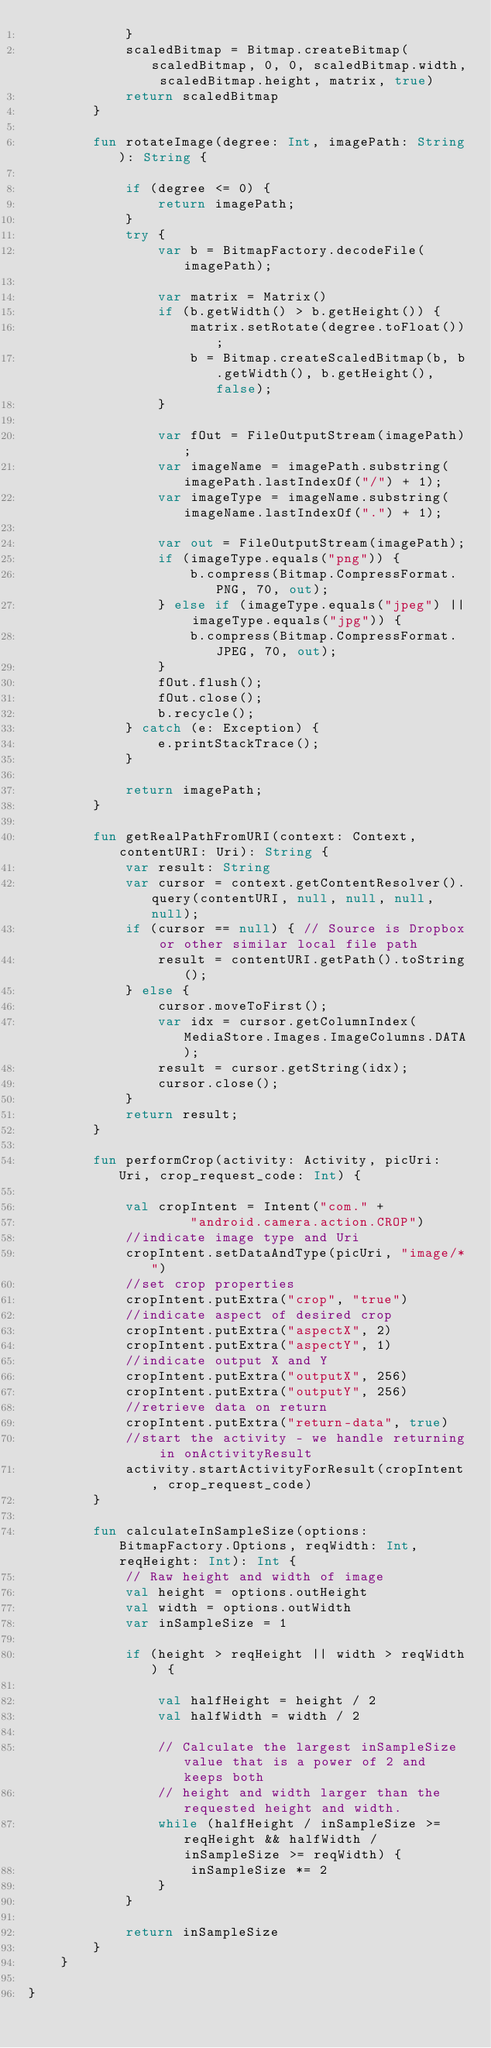<code> <loc_0><loc_0><loc_500><loc_500><_Kotlin_>            }
            scaledBitmap = Bitmap.createBitmap(scaledBitmap, 0, 0, scaledBitmap.width, scaledBitmap.height, matrix, true)
            return scaledBitmap
        }

        fun rotateImage(degree: Int, imagePath: String): String {

            if (degree <= 0) {
                return imagePath;
            }
            try {
                var b = BitmapFactory.decodeFile(imagePath);

                var matrix = Matrix()
                if (b.getWidth() > b.getHeight()) {
                    matrix.setRotate(degree.toFloat());
                    b = Bitmap.createScaledBitmap(b, b.getWidth(), b.getHeight(), false);
                }

                var fOut = FileOutputStream(imagePath);
                var imageName = imagePath.substring(imagePath.lastIndexOf("/") + 1);
                var imageType = imageName.substring(imageName.lastIndexOf(".") + 1);

                var out = FileOutputStream(imagePath);
                if (imageType.equals("png")) {
                    b.compress(Bitmap.CompressFormat.PNG, 70, out);
                } else if (imageType.equals("jpeg") || imageType.equals("jpg")) {
                    b.compress(Bitmap.CompressFormat.JPEG, 70, out);
                }
                fOut.flush();
                fOut.close();
                b.recycle();
            } catch (e: Exception) {
                e.printStackTrace();
            }

            return imagePath;
        }

        fun getRealPathFromURI(context: Context, contentURI: Uri): String {
            var result: String
            var cursor = context.getContentResolver().query(contentURI, null, null, null, null);
            if (cursor == null) { // Source is Dropbox or other similar local file path
                result = contentURI.getPath().toString();
            } else {
                cursor.moveToFirst();
                var idx = cursor.getColumnIndex(MediaStore.Images.ImageColumns.DATA);
                result = cursor.getString(idx);
                cursor.close();
            }
            return result;
        }

        fun performCrop(activity: Activity, picUri: Uri, crop_request_code: Int) {

            val cropIntent = Intent("com." +
                    "android.camera.action.CROP")
            //indicate image type and Uri
            cropIntent.setDataAndType(picUri, "image/*")
            //set crop properties
            cropIntent.putExtra("crop", "true")
            //indicate aspect of desired crop
            cropIntent.putExtra("aspectX", 2)
            cropIntent.putExtra("aspectY", 1)
            //indicate output X and Y
            cropIntent.putExtra("outputX", 256)
            cropIntent.putExtra("outputY", 256)
            //retrieve data on return
            cropIntent.putExtra("return-data", true)
            //start the activity - we handle returning in onActivityResult
            activity.startActivityForResult(cropIntent, crop_request_code)
        }

        fun calculateInSampleSize(options: BitmapFactory.Options, reqWidth: Int, reqHeight: Int): Int {
            // Raw height and width of image
            val height = options.outHeight
            val width = options.outWidth
            var inSampleSize = 1

            if (height > reqHeight || width > reqWidth) {

                val halfHeight = height / 2
                val halfWidth = width / 2

                // Calculate the largest inSampleSize value that is a power of 2 and keeps both
                // height and width larger than the requested height and width.
                while (halfHeight / inSampleSize >= reqHeight && halfWidth / inSampleSize >= reqWidth) {
                    inSampleSize *= 2
                }
            }

            return inSampleSize
        }
    }

}</code> 